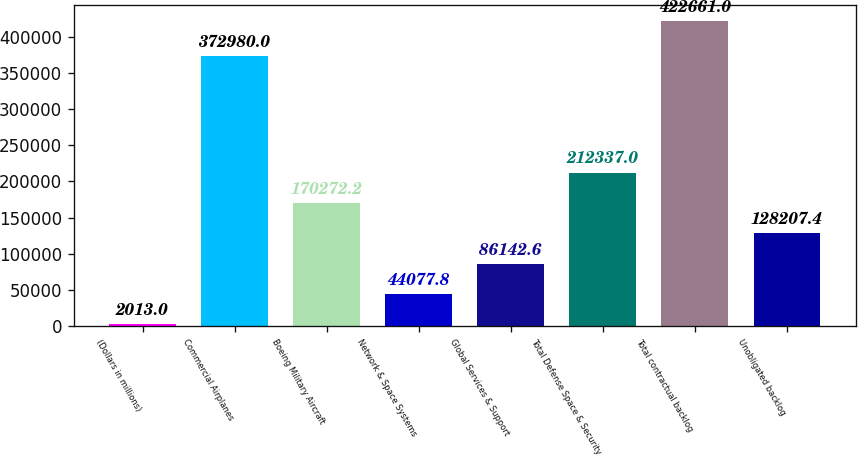Convert chart to OTSL. <chart><loc_0><loc_0><loc_500><loc_500><bar_chart><fcel>(Dollars in millions)<fcel>Commercial Airplanes<fcel>Boeing Military Aircraft<fcel>Network & Space Systems<fcel>Global Services & Support<fcel>Total Defense Space & Security<fcel>Total contractual backlog<fcel>Unobligated backlog<nl><fcel>2013<fcel>372980<fcel>170272<fcel>44077.8<fcel>86142.6<fcel>212337<fcel>422661<fcel>128207<nl></chart> 